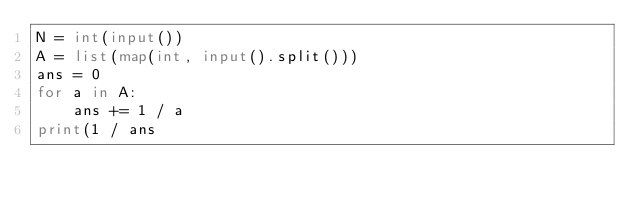<code> <loc_0><loc_0><loc_500><loc_500><_Python_>N = int(input())
A = list(map(int, input().split()))
ans = 0
for a in A:
    ans += 1 / a
print(1 / ans</code> 